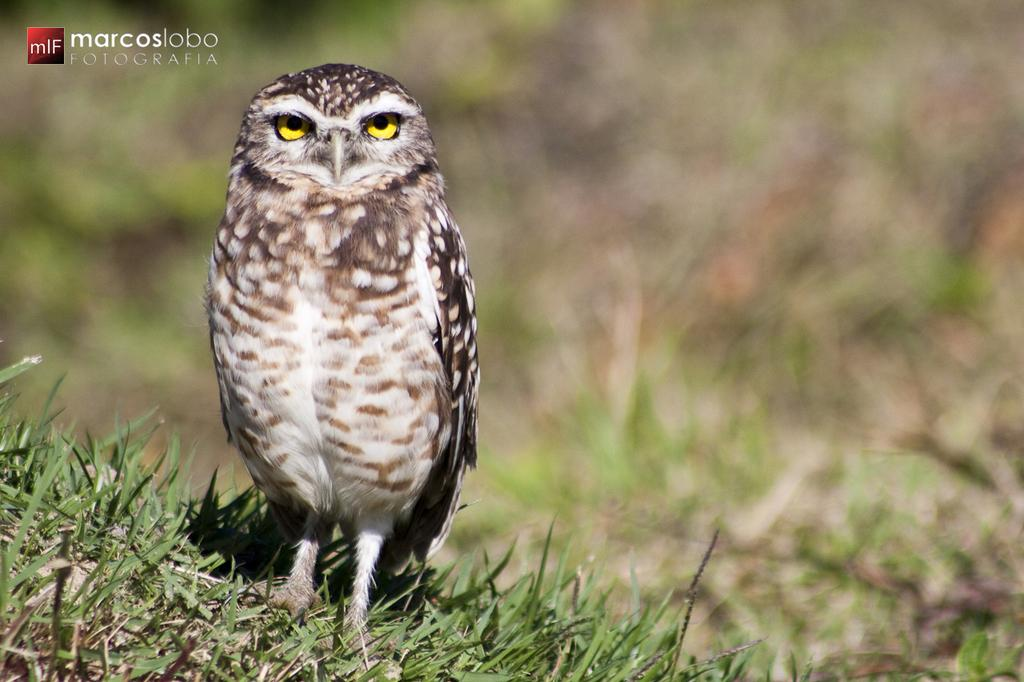What animal is present in the image? There is an owl in the image. Where is the owl located? The owl is on the grass. Can you describe any additional features of the image? There is a watermark in the left top corner of the image. What type of rock can be seen in the image? There is no rock present in the image; it features an owl on the grass. How many geese are visible in the image? There are no geese present in the image; it features an owl on the grass. 